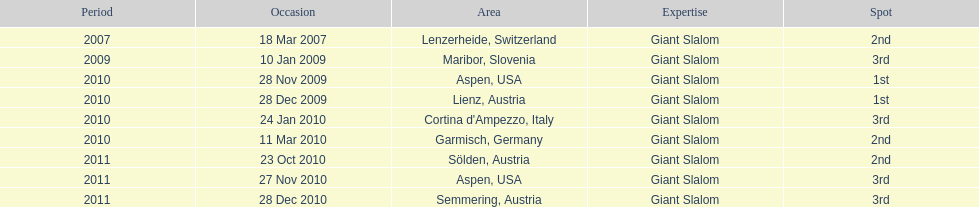What was the finishing place of the last race in december 2010? 3rd. 